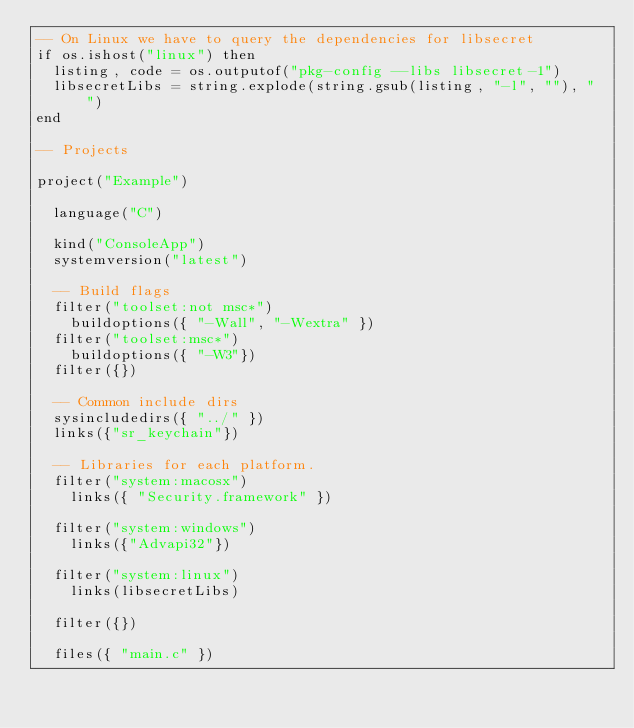Convert code to text. <code><loc_0><loc_0><loc_500><loc_500><_Lua_>-- On Linux we have to query the dependencies for libsecret
if os.ishost("linux") then
	listing, code = os.outputof("pkg-config --libs libsecret-1")
	libsecretLibs = string.explode(string.gsub(listing, "-l", ""), " ")
end

-- Projects

project("Example")

	language("C")

	kind("ConsoleApp")
	systemversion("latest")

	-- Build flags
	filter("toolset:not msc*")
		buildoptions({ "-Wall", "-Wextra" })
	filter("toolset:msc*")
		buildoptions({ "-W3"})
	filter({})

	-- Common include dirs
	sysincludedirs({ "../" })
	links({"sr_keychain"})

	-- Libraries for each platform.
	filter("system:macosx")
		links({ "Security.framework" })

	filter("system:windows")
		links({"Advapi32"})

	filter("system:linux")
		links(libsecretLibs)
		
	filter({})

	files({ "main.c" })

</code> 